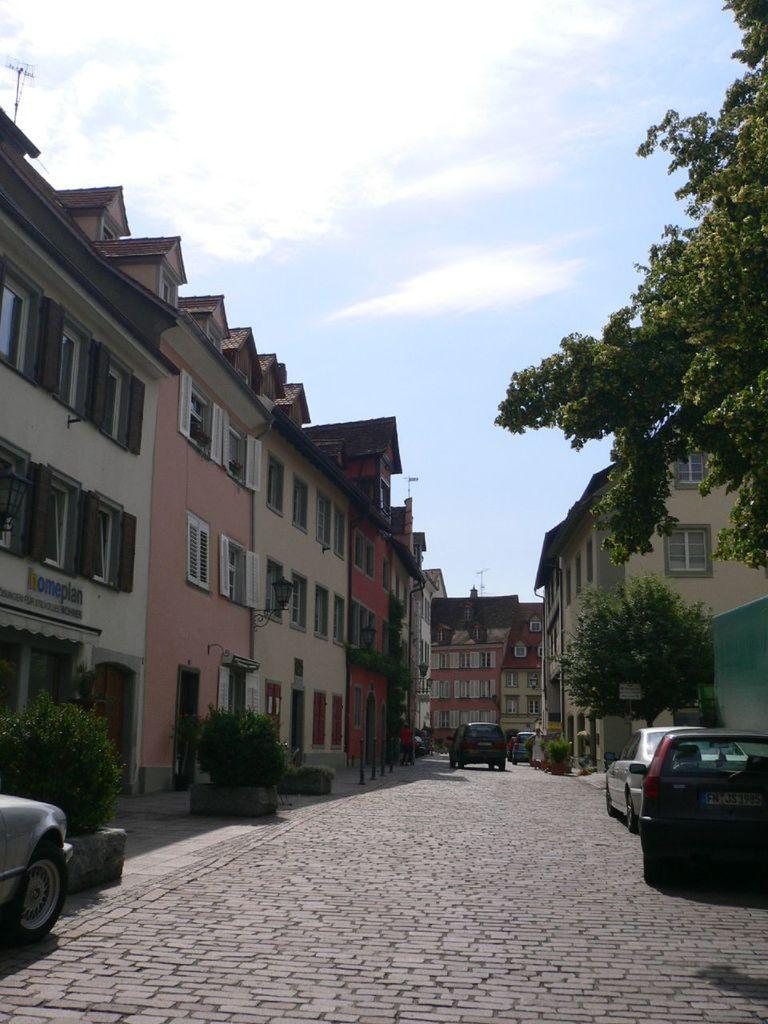What type of structures can be seen in the image? There are buildings in the image. What other elements are present in the image besides buildings? There are plants, vehicles, trees, and lamps attached to the walls in the image. What is the condition of the sky in the image? The sky is cloudy in the image. Where is the toothpaste located in the image? There is no toothpaste present in the image. What type of machine can be seen operating in the image? There is no machine present in the image. 